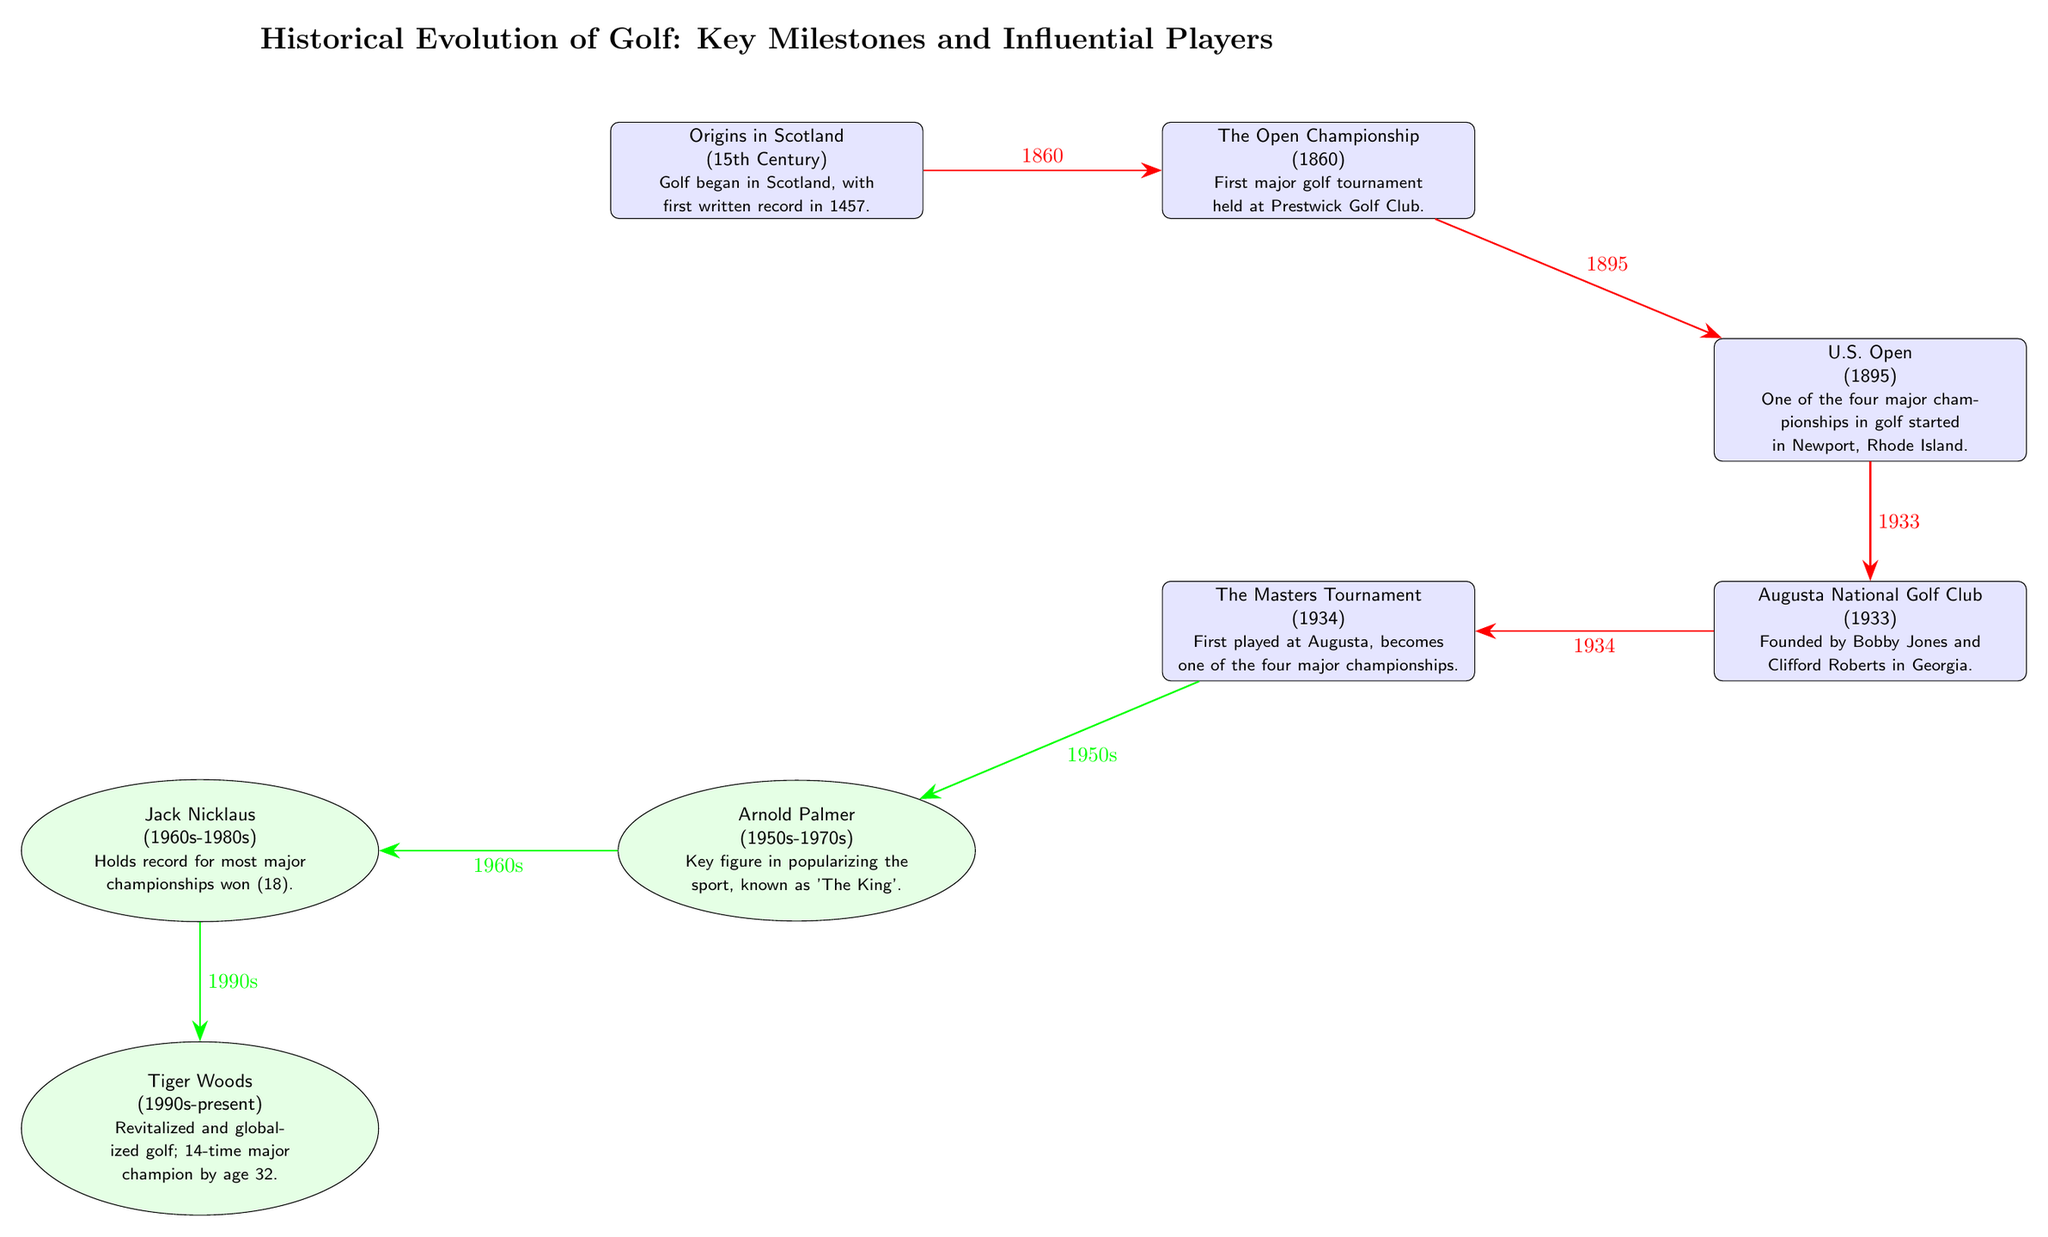What is the first recorded milestone in the diagram? The first recorded milestone in the diagram is located at the top left node, which states that Golf began in Scotland, with the first written record in 1457. This can be identified as the beginning point of the historical timeline.
Answer: Origins in Scotland (15th Century) How many major championships are mentioned in the diagram? There are four major championships mentioned in the diagram: The Open Championship, U.S. Open, The Masters Tournament, and Augusta National Golf Club. By counting the nodes that specify major championships, we find a total of four.
Answer: 4 Which player is noted for holding the record for the most major championships won? The second player node from the left specifies that Jack Nicklaus holds the record for most major championships won, indicating his significance in the history of golf.
Answer: Jack Nicklaus What year did The Masters Tournament begin? The Masters Tournament node contains the information that it was first played in 1934. Thus, by looking at the date associated with this node, we can find the answer.
Answer: 1934 Which player is described as revitalizing and globalizing golf? The definition provided on the rightmost player node identifies Tiger Woods as having revitalized and globalized golf. This is directly stated in the text under his name.
Answer: Tiger Woods What is the relationship between Arnold Palmer and Jack Nicklaus in the diagram? The diagram establishes a sequential relationship, indicating that Arnold Palmer, who became prominent in the 1950s, influenced or preceded Jack Nicklaus, who rose to fame in the 1960s. This is shown through the green arrow connecting their respective nodes.
Answer: Sequential influence What milestone does The Open Championship relate to in terms of historical years? The Open Championship is directly linked to the year 1860, which is noted in a red arrow leading from it to the U.S. Open milestone, indicating its temporal significance in the timeline.
Answer: 1860 What landmark golf club was founded by Bobby Jones and Clifford Roberts? The Augusta National Golf Club node explicitly states it was founded by Bobby Jones and Clifford Roberts in Georgia, which can be discerned by reading the text within the node.
Answer: Augusta National Golf Club How are the players in the diagram arranged in terms of their active years? The players are arranged in chronological order, starting with Arnold Palmer in the 1950s, followed by Jack Nicklaus in the 1960s, and ending with Tiger Woods, who is active from the 1990s to the present. This sequencing shows the historical progression of influential players in golf.
Answer: Chronological order 